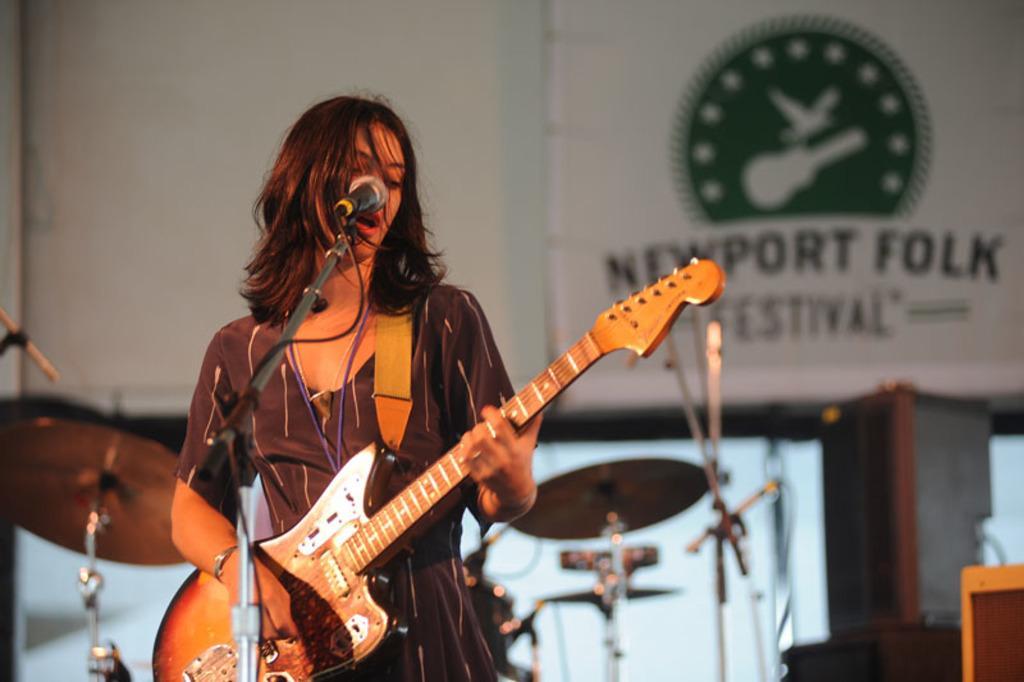Please provide a concise description of this image. This picture shows a woman standing and playing a guitar and singing with the help of a microphone and we see a hoarding back of her 